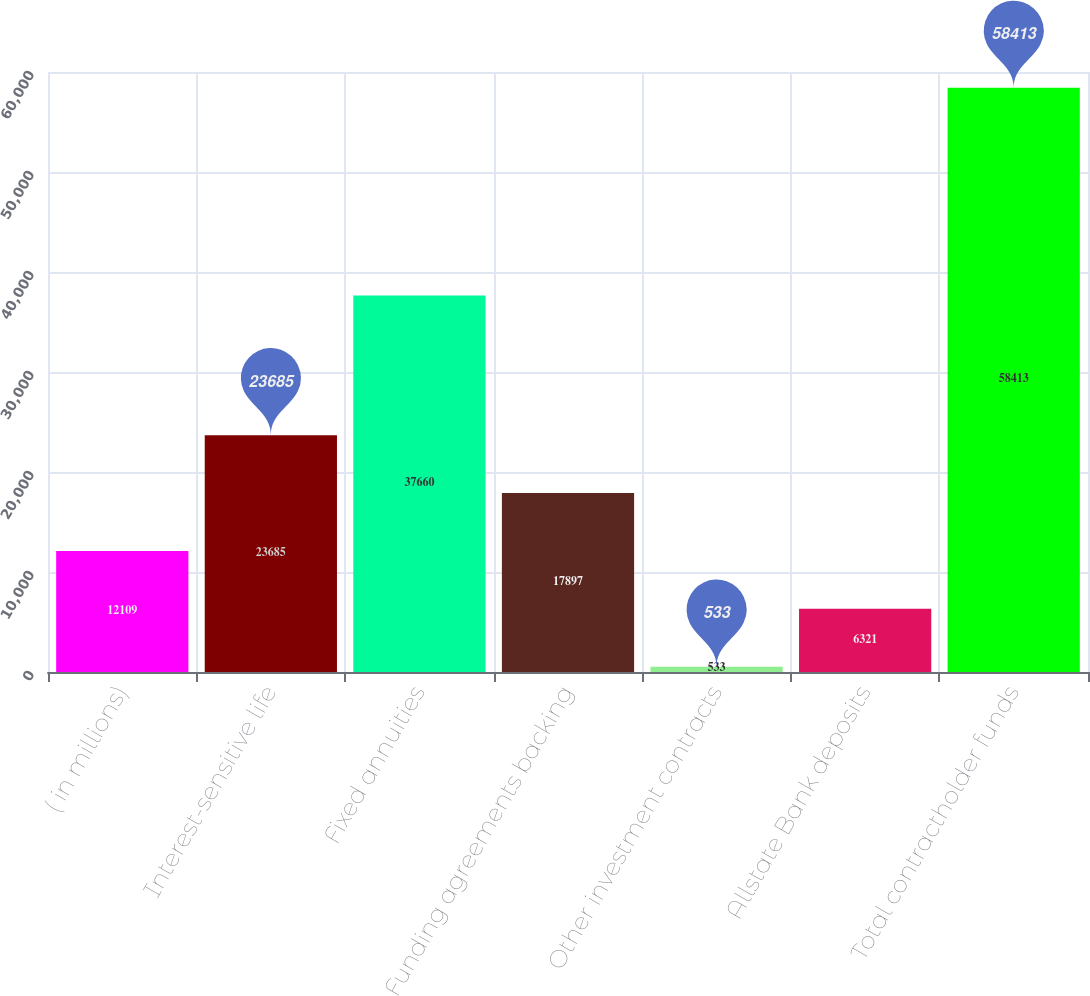Convert chart. <chart><loc_0><loc_0><loc_500><loc_500><bar_chart><fcel>( in millions)<fcel>Interest-sensitive life<fcel>Fixed annuities<fcel>Funding agreements backing<fcel>Other investment contracts<fcel>Allstate Bank deposits<fcel>Total contractholder funds<nl><fcel>12109<fcel>23685<fcel>37660<fcel>17897<fcel>533<fcel>6321<fcel>58413<nl></chart> 